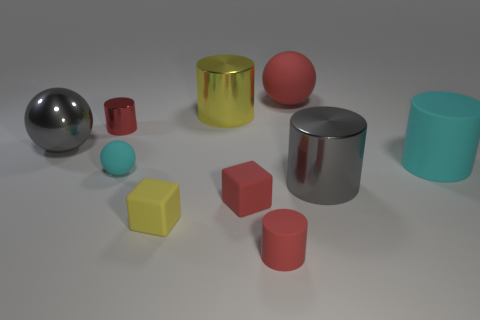Subtract all large cyan rubber cylinders. How many cylinders are left? 4 Subtract all yellow cylinders. How many cylinders are left? 4 Subtract all cubes. How many objects are left? 8 Add 4 tiny yellow balls. How many tiny yellow balls exist? 4 Subtract 0 purple cylinders. How many objects are left? 10 Subtract 1 cylinders. How many cylinders are left? 4 Subtract all green cylinders. Subtract all cyan balls. How many cylinders are left? 5 Subtract all brown spheres. How many gray cubes are left? 0 Subtract all cyan matte cylinders. Subtract all metallic balls. How many objects are left? 8 Add 6 large gray metallic things. How many large gray metallic things are left? 8 